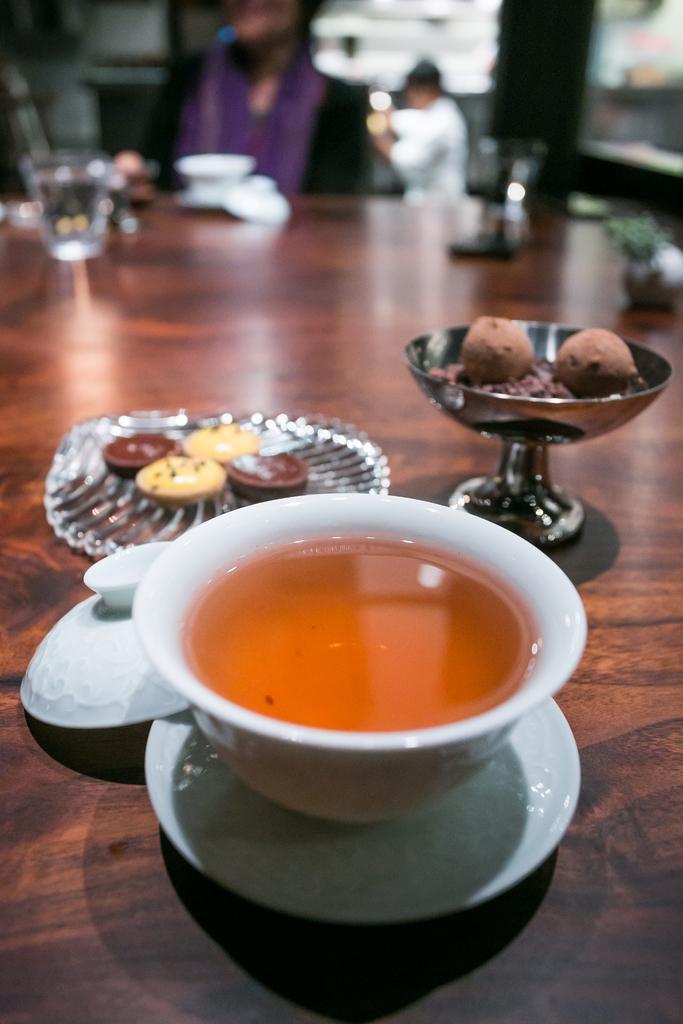Can you describe this image briefly? In this image we can see some food in a bowl, a plate and in a cup. We can also see a glass and the lid of a bowl placed aside. On the backside we can see two people. 